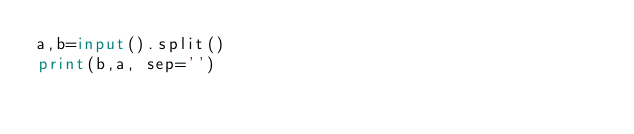Convert code to text. <code><loc_0><loc_0><loc_500><loc_500><_Python_>a,b=input().split()
print(b,a, sep='')</code> 